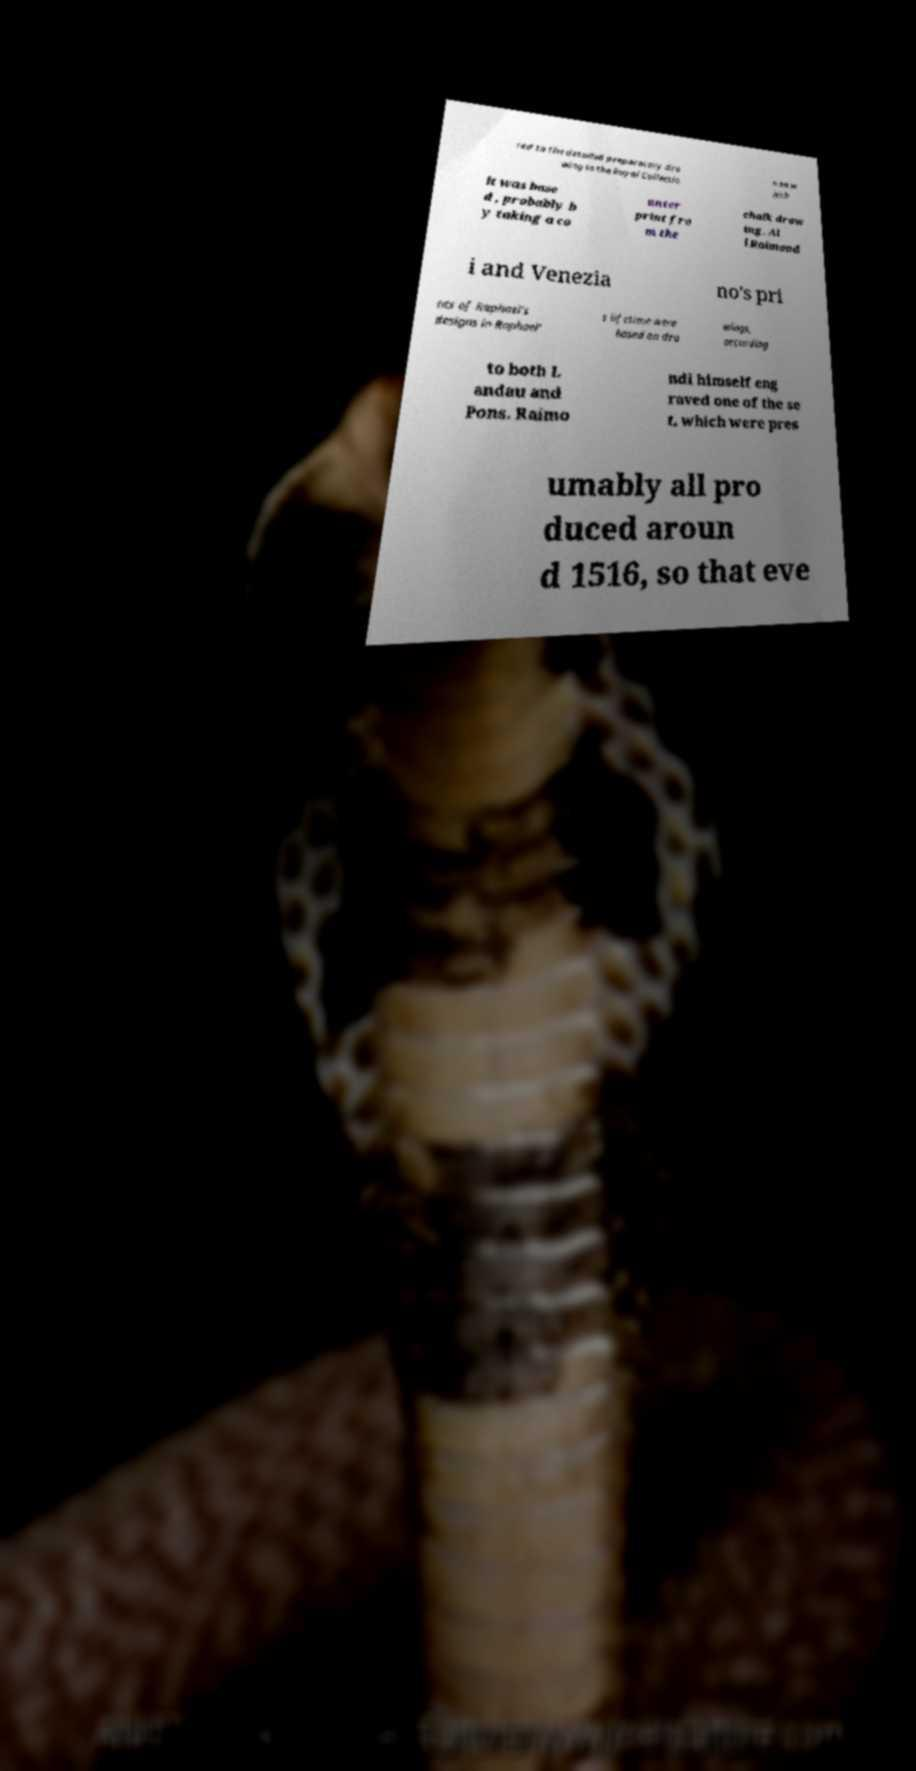Could you assist in decoding the text presented in this image and type it out clearly? red to the detailed preparatory dra wing in the Royal Collectio n on w hich it was base d , probably b y taking a co unter print fro m the chalk draw ing. Al l Raimond i and Venezia no's pri nts of Raphael's designs in Raphael' s lifetime were based on dra wings, according to both L andau and Pons. Raimo ndi himself eng raved one of the se t, which were pres umably all pro duced aroun d 1516, so that eve 